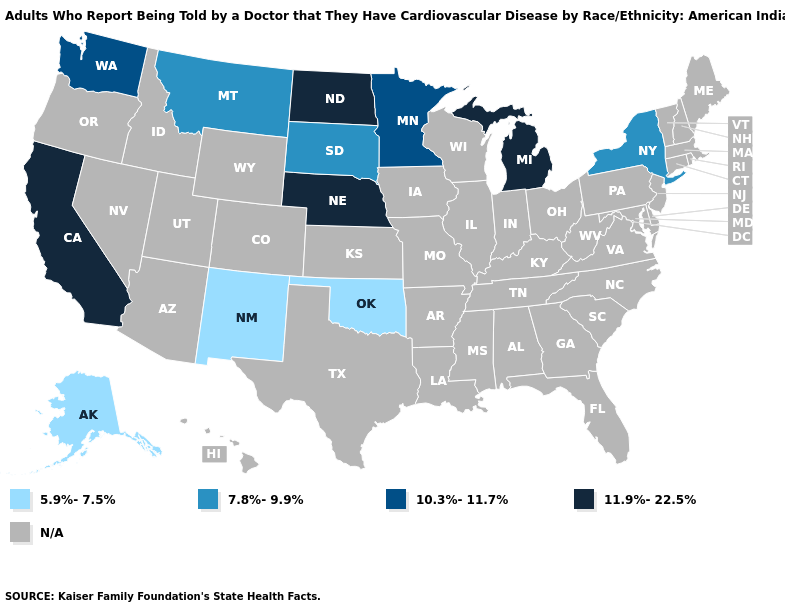What is the highest value in the Northeast ?
Keep it brief. 7.8%-9.9%. What is the value of Maine?
Write a very short answer. N/A. Which states have the lowest value in the USA?
Write a very short answer. Alaska, New Mexico, Oklahoma. What is the value of New York?
Concise answer only. 7.8%-9.9%. What is the value of Wyoming?
Answer briefly. N/A. Does New Mexico have the lowest value in the West?
Give a very brief answer. Yes. Which states have the lowest value in the South?
Concise answer only. Oklahoma. Name the states that have a value in the range 5.9%-7.5%?
Short answer required. Alaska, New Mexico, Oklahoma. Which states have the lowest value in the Northeast?
Answer briefly. New York. What is the lowest value in the West?
Give a very brief answer. 5.9%-7.5%. What is the value of Ohio?
Be succinct. N/A. 